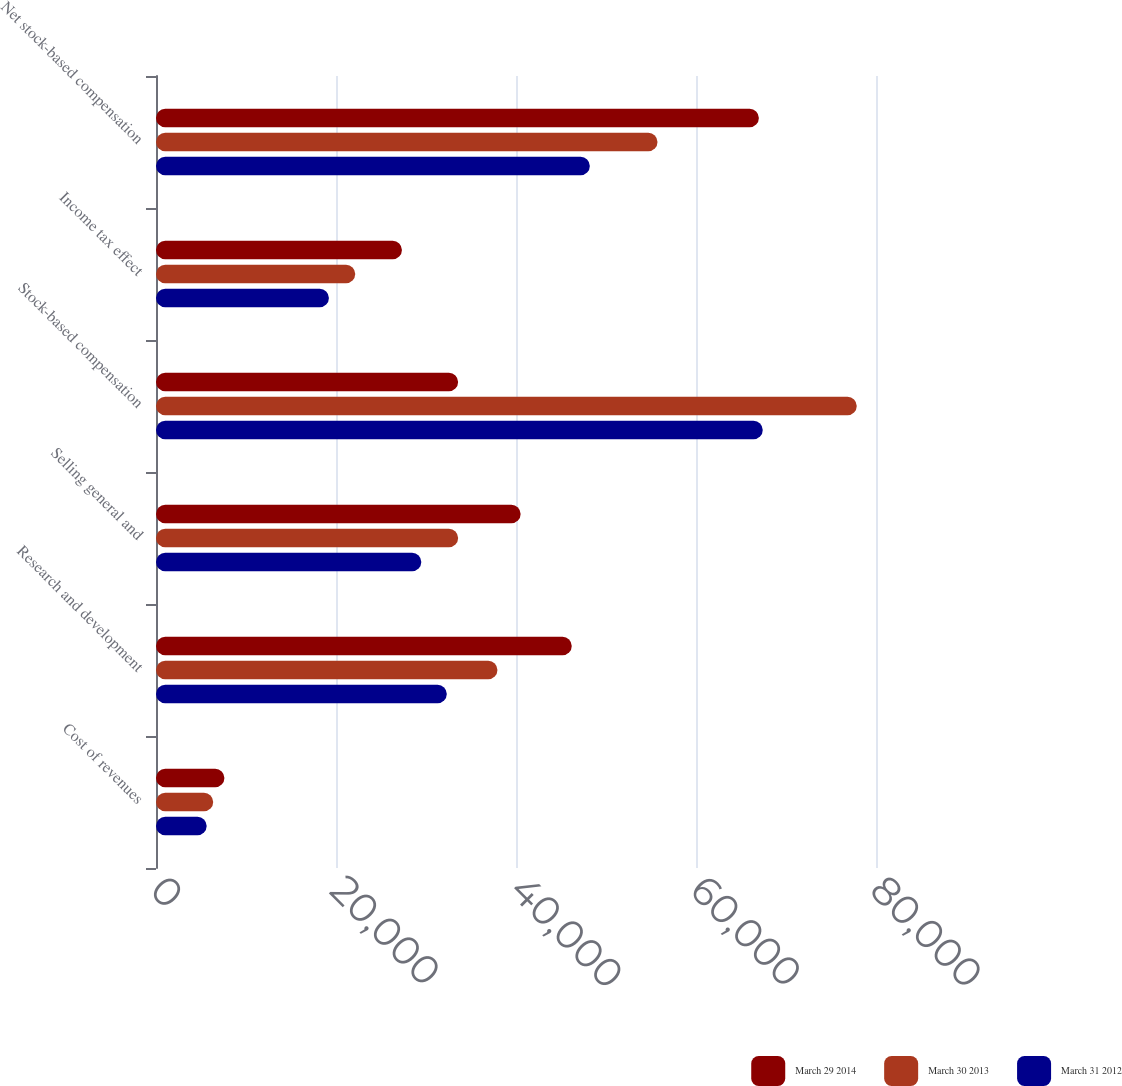Convert chart to OTSL. <chart><loc_0><loc_0><loc_500><loc_500><stacked_bar_chart><ecel><fcel>Cost of revenues<fcel>Research and development<fcel>Selling general and<fcel>Stock-based compensation<fcel>Income tax effect<fcel>Net stock-based compensation<nl><fcel>March 29 2014<fcel>7602<fcel>46197<fcel>40515<fcel>33569<fcel>27327<fcel>66987<nl><fcel>March 30 2013<fcel>6356<fcel>37937<fcel>33569<fcel>77862<fcel>22137<fcel>55725<nl><fcel>March 31 2012<fcel>5630<fcel>32310<fcel>29478<fcel>67418<fcel>19214<fcel>48204<nl></chart> 